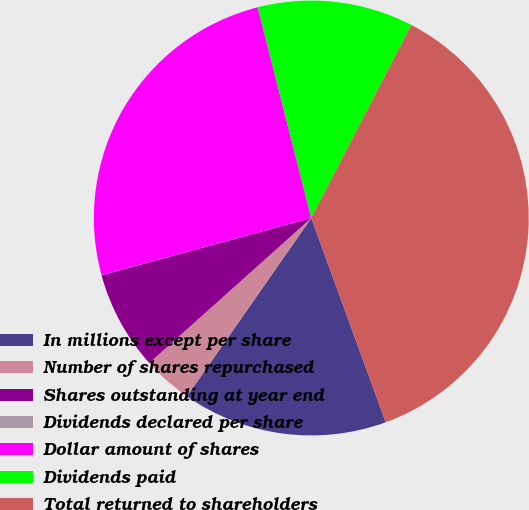<chart> <loc_0><loc_0><loc_500><loc_500><pie_chart><fcel>In millions except per share<fcel>Number of shares repurchased<fcel>Shares outstanding at year end<fcel>Dividends declared per share<fcel>Dollar amount of shares<fcel>Dividends paid<fcel>Total returned to shareholders<nl><fcel>15.25%<fcel>3.69%<fcel>7.38%<fcel>0.01%<fcel>25.27%<fcel>11.57%<fcel>36.83%<nl></chart> 